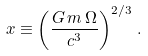Convert formula to latex. <formula><loc_0><loc_0><loc_500><loc_500>x \equiv \left ( \frac { G \, m \, \Omega } { c ^ { 3 } } \right ) ^ { 2 / 3 } \, .</formula> 